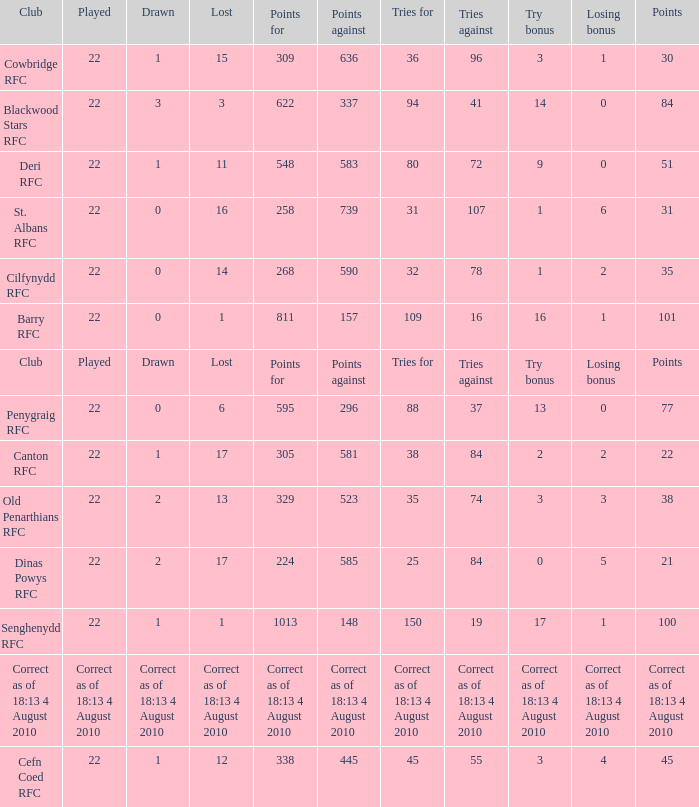What is the losing bonus when drawn was 0, and there were 101 points? 1.0. 